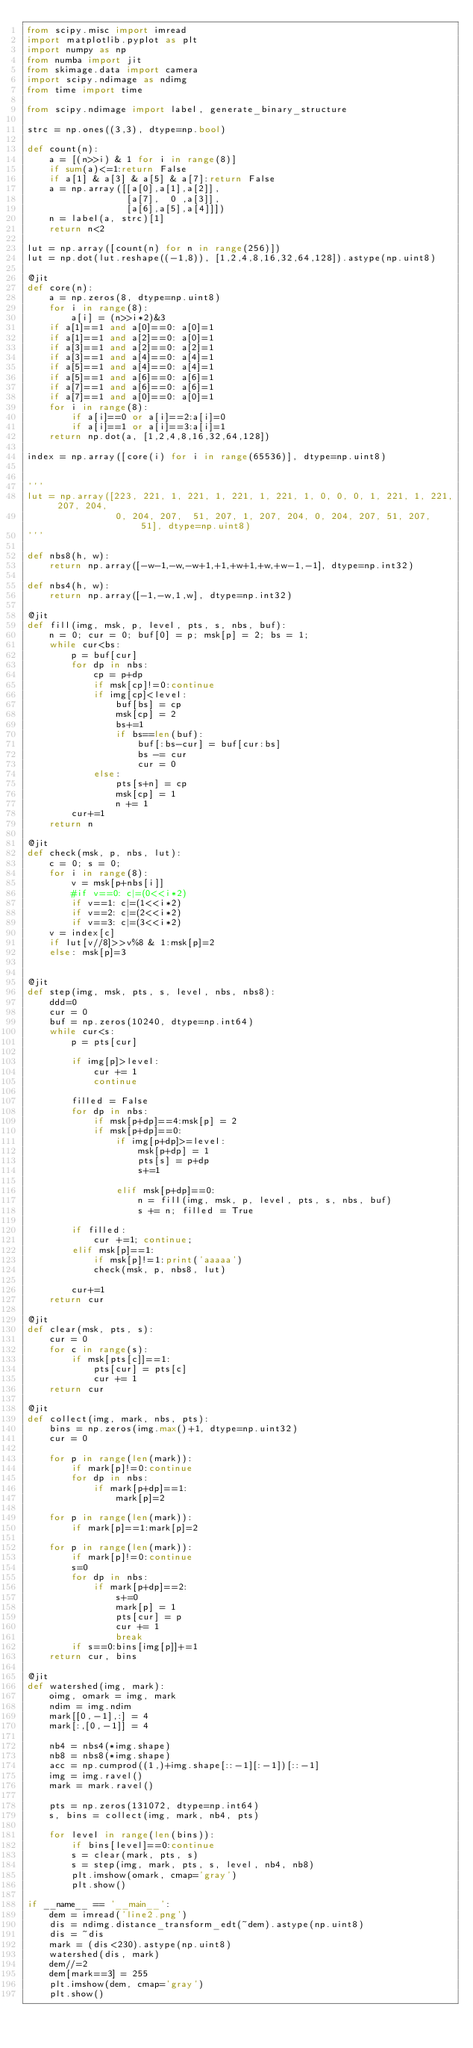<code> <loc_0><loc_0><loc_500><loc_500><_Python_>from scipy.misc import imread
import matplotlib.pyplot as plt
import numpy as np
from numba import jit
from skimage.data import camera
import scipy.ndimage as ndimg
from time import time

from scipy.ndimage import label, generate_binary_structure

strc = np.ones((3,3), dtype=np.bool)

def count(n):
    a = [(n>>i) & 1 for i in range(8)]
    if sum(a)<=1:return False
    if a[1] & a[3] & a[5] & a[7]:return False
    a = np.array([[a[0],a[1],a[2]],
                  [a[7],  0 ,a[3]],
                  [a[6],a[5],a[4]]])
    n = label(a, strc)[1]
    return n<2

lut = np.array([count(n) for n in range(256)])
lut = np.dot(lut.reshape((-1,8)), [1,2,4,8,16,32,64,128]).astype(np.uint8)

@jit
def core(n):
    a = np.zeros(8, dtype=np.uint8)
    for i in range(8):
        a[i] = (n>>i*2)&3
    if a[1]==1 and a[0]==0: a[0]=1
    if a[1]==1 and a[2]==0: a[0]=1
    if a[3]==1 and a[2]==0: a[2]=1
    if a[3]==1 and a[4]==0: a[4]=1
    if a[5]==1 and a[4]==0: a[4]=1
    if a[5]==1 and a[6]==0: a[6]=1
    if a[7]==1 and a[6]==0: a[6]=1
    if a[7]==1 and a[0]==0: a[0]=1
    for i in range(8):
        if a[i]==0 or a[i]==2:a[i]=0
        if a[i]==1 or a[i]==3:a[i]=1
    return np.dot(a, [1,2,4,8,16,32,64,128])

index = np.array([core(i) for i in range(65536)], dtype=np.uint8)


'''
lut = np.array([223, 221, 1, 221, 1, 221, 1, 221, 1, 0, 0, 0, 1, 221, 1, 221, 207, 204,
                0, 204, 207,  51, 207, 1, 207, 204, 0, 204, 207, 51, 207, 51], dtype=np.uint8)
'''

def nbs8(h, w):
    return np.array([-w-1,-w,-w+1,+1,+w+1,+w,+w-1,-1], dtype=np.int32)

def nbs4(h, w):
    return np.array([-1,-w,1,w], dtype=np.int32)

@jit
def fill(img, msk, p, level, pts, s, nbs, buf):
    n = 0; cur = 0; buf[0] = p; msk[p] = 2; bs = 1;
    while cur<bs:
        p = buf[cur]
        for dp in nbs:
            cp = p+dp
            if msk[cp]!=0:continue
            if img[cp]<level:
                buf[bs] = cp
                msk[cp] = 2
                bs+=1
                if bs==len(buf):
                    buf[:bs-cur] = buf[cur:bs]
                    bs -= cur
                    cur = 0
            else:
                pts[s+n] = cp
                msk[cp] = 1
                n += 1
        cur+=1
    return n

@jit
def check(msk, p, nbs, lut):
    c = 0; s = 0;
    for i in range(8):
        v = msk[p+nbs[i]]
        #if v==0: c|=(0<<i*2)
        if v==1: c|=(1<<i*2)
        if v==2: c|=(2<<i*2)
        if v==3: c|=(3<<i*2)
    v = index[c]
    if lut[v//8]>>v%8 & 1:msk[p]=2
    else: msk[p]=3


@jit
def step(img, msk, pts, s, level, nbs, nbs8):
    ddd=0
    cur = 0
    buf = np.zeros(10240, dtype=np.int64)
    while cur<s:
        p = pts[cur]

        if img[p]>level:
            cur += 1
            continue

        filled = False
        for dp in nbs:
            if msk[p+dp]==4:msk[p] = 2
            if msk[p+dp]==0:
                if img[p+dp]>=level:
                    msk[p+dp] = 1
                    pts[s] = p+dp
                    s+=1
                    
                elif msk[p+dp]==0:
                    n = fill(img, msk, p, level, pts, s, nbs, buf)
                    s += n; filled = True
        
        if filled:
            cur +=1; continue;
        elif msk[p]==1:
            if msk[p]!=1:print('aaaaa')
            check(msk, p, nbs8, lut)

        cur+=1
    return cur

@jit
def clear(msk, pts, s):
    cur = 0
    for c in range(s):
        if msk[pts[c]]==1:
            pts[cur] = pts[c]
            cur += 1
    return cur
        
@jit
def collect(img, mark, nbs, pts):
    bins = np.zeros(img.max()+1, dtype=np.uint32)
    cur = 0
    
    for p in range(len(mark)):
        if mark[p]!=0:continue
        for dp in nbs:
            if mark[p+dp]==1:
                mark[p]=2

    for p in range(len(mark)):
        if mark[p]==1:mark[p]=2

    for p in range(len(mark)):
        if mark[p]!=0:continue
        s=0
        for dp in nbs:
            if mark[p+dp]==2:
                s+=0
                mark[p] = 1
                pts[cur] = p
                cur += 1
                break
        if s==0:bins[img[p]]+=1
    return cur, bins

@jit
def watershed(img, mark):
    oimg, omark = img, mark
    ndim = img.ndim
    mark[[0,-1],:] = 4
    mark[:,[0,-1]] = 4
    
    nb4 = nbs4(*img.shape)
    nb8 = nbs8(*img.shape)
    acc = np.cumprod((1,)+img.shape[::-1][:-1])[::-1]
    img = img.ravel()
    mark = mark.ravel()

    pts = np.zeros(131072, dtype=np.int64)
    s, bins = collect(img, mark, nb4, pts)
        
    for level in range(len(bins)):
        if bins[level]==0:continue
        s = clear(mark, pts, s)
        s = step(img, mark, pts, s, level, nb4, nb8)
        plt.imshow(omark, cmap='gray')
        plt.show()

if __name__ == '__main__':
    dem = imread('line2.png')
    dis = ndimg.distance_transform_edt(~dem).astype(np.uint8)
    dis = ~dis
    mark = (dis<230).astype(np.uint8)
    watershed(dis, mark)
    dem//=2
    dem[mark==3] = 255
    plt.imshow(dem, cmap='gray')
    plt.show()</code> 